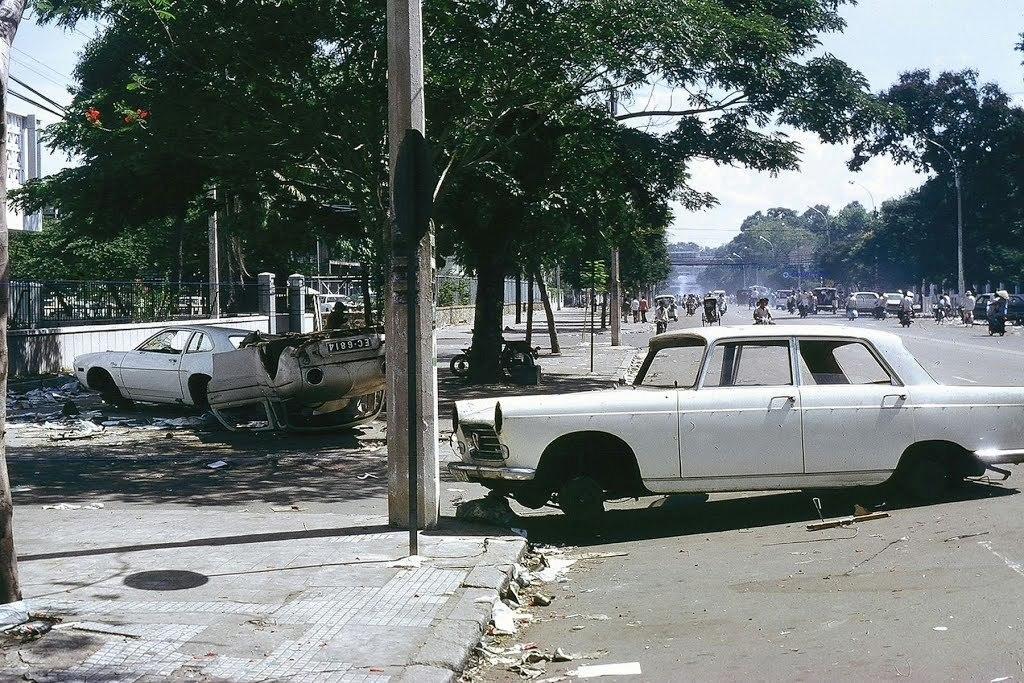Please provide a concise description of this image. In this picture I can see vehicles on the road. On the left side I can see trees, poles, a wall and a fence. In the background I can see the sky. 